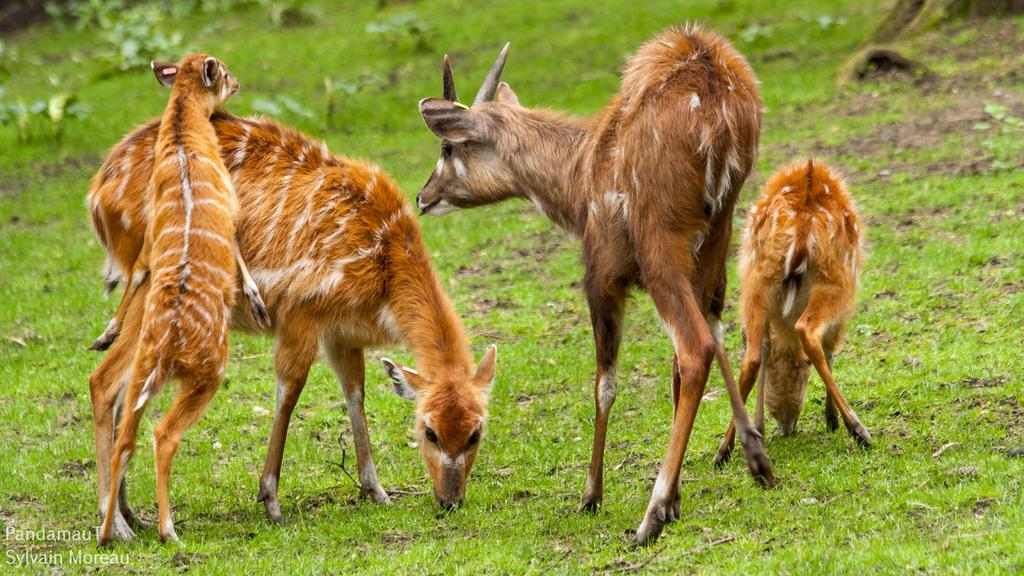What animal can be seen in the image? There is a deer in the image. Where is the deer located? The deer is on a grassland. What is written or depicted at the bottom side of the image? There is text at the bottom side of the image. Can you see a snail crawling on the board in the image? There is no snail or board present in the image. 